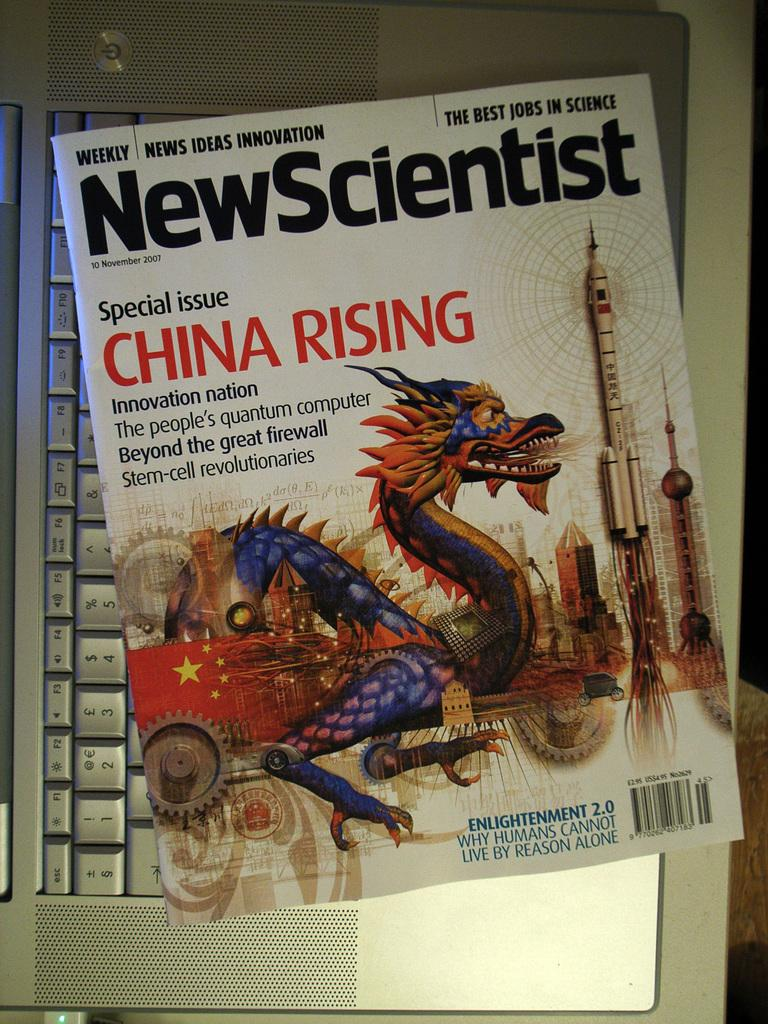Provide a one-sentence caption for the provided image. A magazine cover for new scientist wit hthe special issue title china rising. 